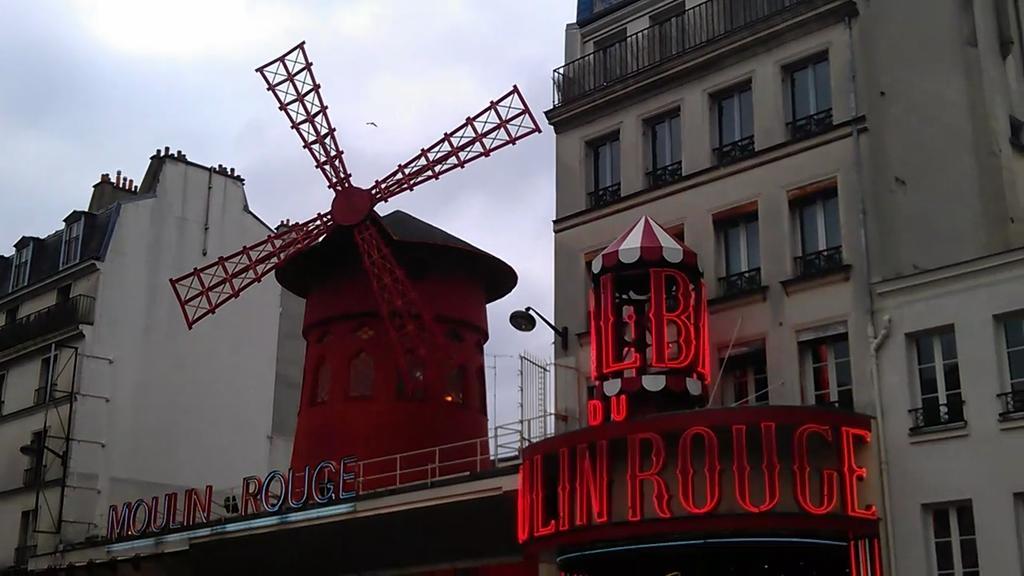Describe this image in one or two sentences. Here we can see buildings, windows, and boards. In the background there is sky. 